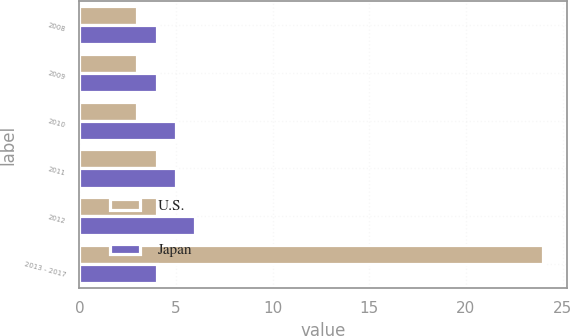<chart> <loc_0><loc_0><loc_500><loc_500><stacked_bar_chart><ecel><fcel>2008<fcel>2009<fcel>2010<fcel>2011<fcel>2012<fcel>2013 - 2017<nl><fcel>U.S.<fcel>3<fcel>3<fcel>3<fcel>4<fcel>4<fcel>24<nl><fcel>Japan<fcel>4<fcel>4<fcel>5<fcel>5<fcel>6<fcel>4<nl></chart> 